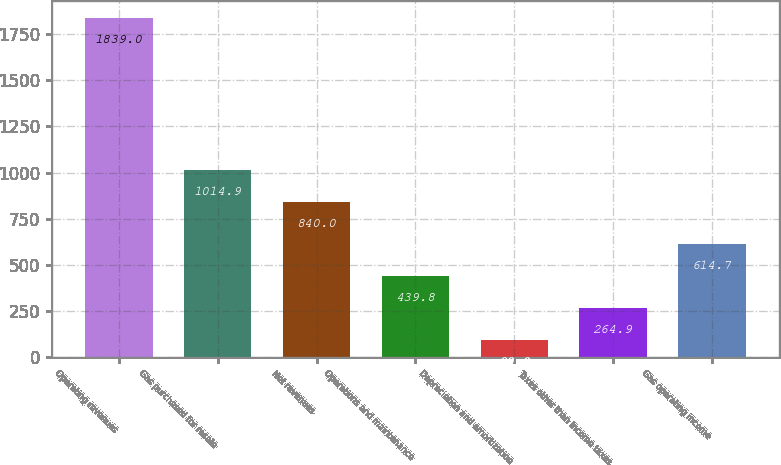Convert chart. <chart><loc_0><loc_0><loc_500><loc_500><bar_chart><fcel>Operating revenues<fcel>Gas purchased for resale<fcel>Net revenues<fcel>Operations and maintenance<fcel>Depreciation and amortization<fcel>Taxes other than income taxes<fcel>Gas operating income<nl><fcel>1839<fcel>1014.9<fcel>840<fcel>439.8<fcel>90<fcel>264.9<fcel>614.7<nl></chart> 